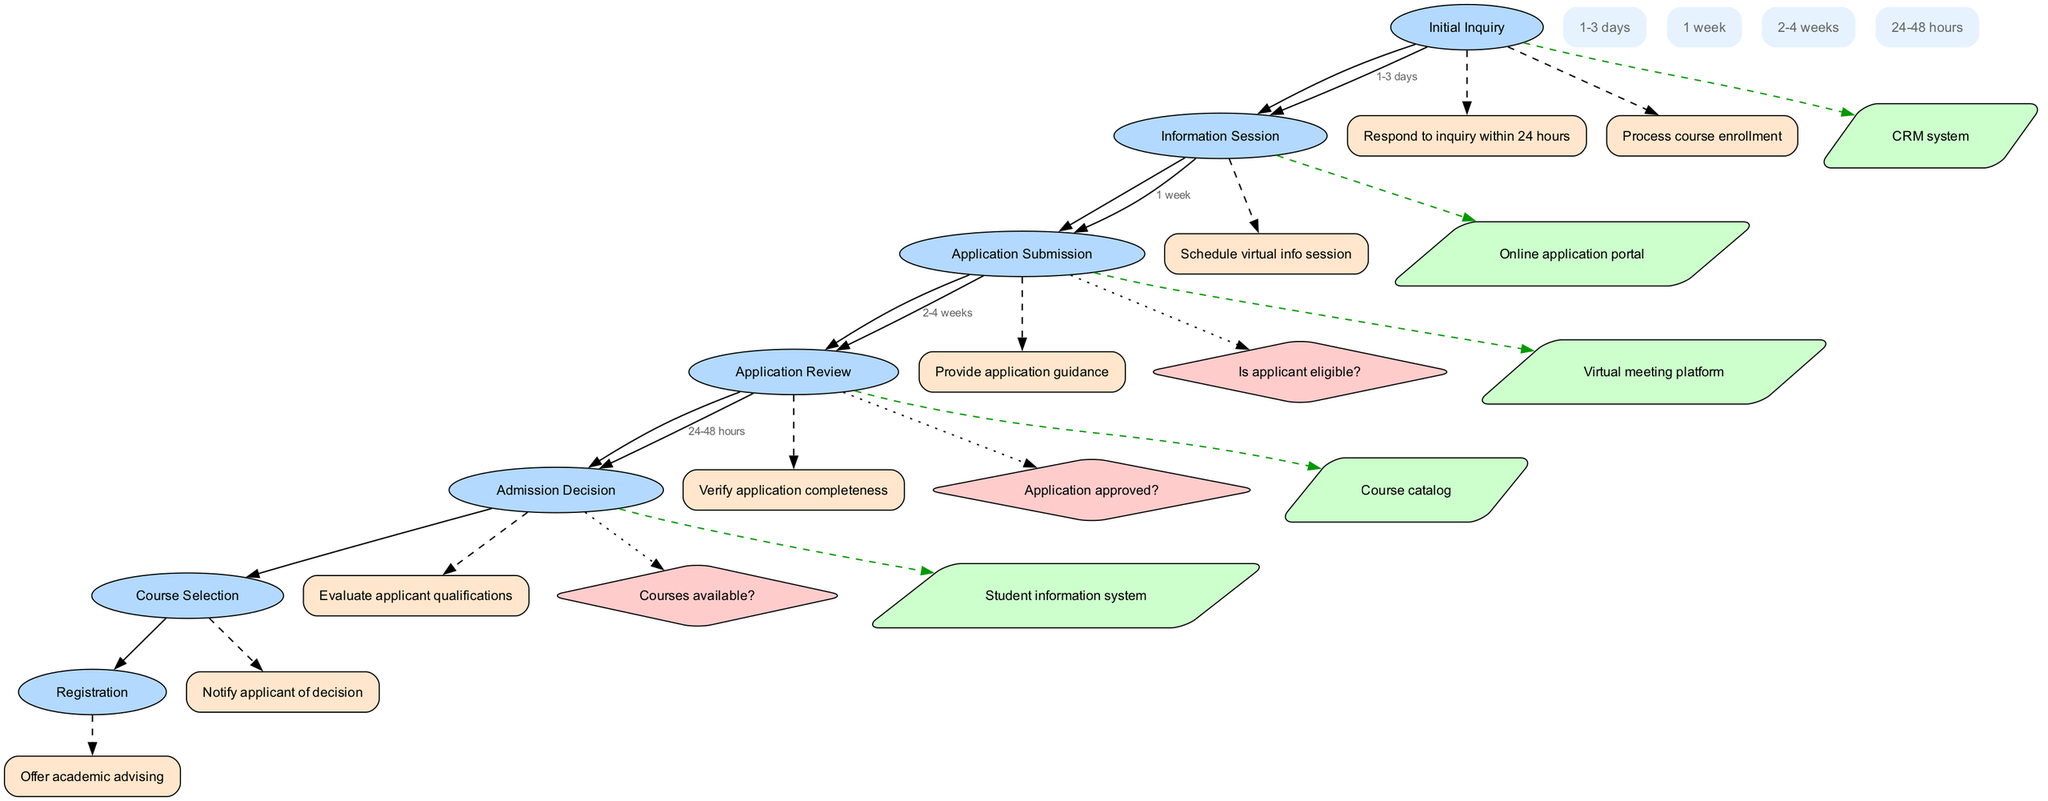What is the first stage of the pathway? The diagram starts with the first stage labeled as "Initial Inquiry", which is depicted at the top of the pathway.
Answer: Initial Inquiry How many stages are there in total? By counting the nodes representing the stages in the diagram, there are seven distinct stages listed from "Initial Inquiry" to "Registration".
Answer: 7 What action follows the "Application Review" stage? The action that follows the "Application Review" stage is indicated to be "Notify applicant of decision", which connects directly after the review process.
Answer: Notify applicant of decision What is the decision made after "Application Submission"? The decision made after the "Application Submission" stage is "Is applicant eligible?", which is shown as a decision point following the application submission.
Answer: Is applicant eligible? Which resource is linked with the "Course Selection" stage? The resource that is connected to the "Course Selection" stage is the "Course catalog", as indicated by the dashed edge leading from the stage to the resource node.
Answer: Course catalog What is the timeline for the "Admission Decision" stage? The timeline indicated for the "Admission Decision" stage is "24-48 hours", which is shown as a label on the edge connecting this stage to the next one.
Answer: 24-48 hours What action is represented by the node that follows "Registration"? There is no action node directly following "Registration", as it is the last stage in the pathway, hence no subsequent action is indicated.
Answer: None Which stage comes before "Course Selection"? The stage that comes immediately before "Course Selection" is labeled as "Admission Decision", which is directly preceding this stage in the diagram.
Answer: Admission Decision What decision follows the "Application Review" stage? The decision that follows the "Application Review" stage is "Application approved?", which assesses the outcome of the review process before progressing.
Answer: Application approved? 